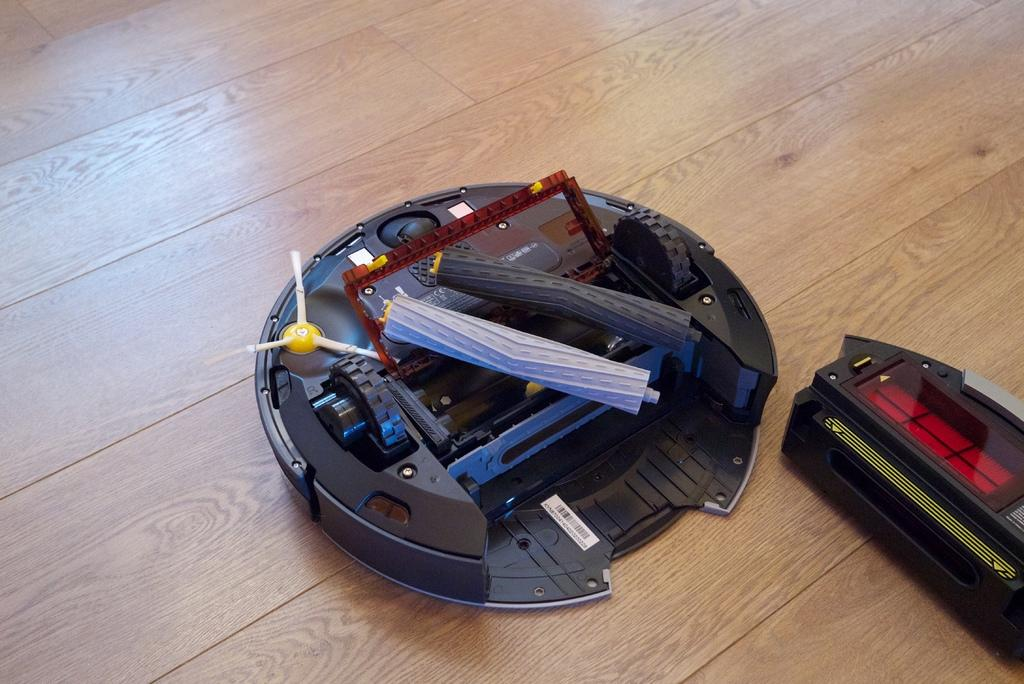How many electronic devices are visible in the image? There are two electronic devices in the image. What is the surface on which the electronic devices are placed? The electronic devices are on a wooden surface. Where are the kittens hiding in the image? There are no kittens present in the image. What type of spoon is being used by the scarecrow in the image? There is no scarecrow or spoon present in the image. 